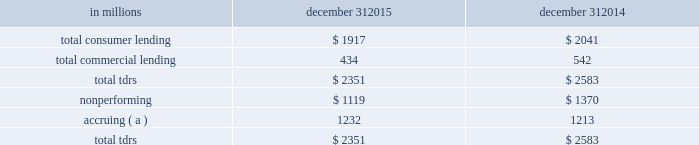Troubled debt restructurings ( tdrs ) a tdr is a loan whose terms have been restructured in a manner that grants a concession to a borrower experiencing financial difficulty .
Tdrs result from our loss mitigation activities , and include rate reductions , principal forgiveness , postponement/reduction of scheduled amortization , and extensions , which are intended to minimize economic loss and to avoid foreclosure or repossession of collateral .
Additionally , tdrs also result from borrowers that have been discharged from personal liability through chapter 7 bankruptcy and have not formally reaffirmed their loan obligations to pnc .
In those situations where principal is forgiven , the amount of such principal forgiveness is immediately charged off .
Some tdrs may not ultimately result in the full collection of principal and interest , as restructured , and result in potential incremental losses .
These potential incremental losses have been factored into our overall alll estimate .
The level of any subsequent defaults will likely be affected by future economic conditions .
Once a loan becomes a tdr , it will continue to be reported as a tdr until it is ultimately repaid in full , the collateral is foreclosed upon , or it is fully charged off .
We held specific reserves in the alll of $ .3 billion and $ .4 billion at december 31 , 2015 and december 31 , 2014 , respectively , for the total tdr portfolio .
Table 61 : summary of troubled debt restructurings in millions december 31 december 31 .
( a ) accruing loans include consumer credit card loans and loans that have demonstrated a period of at least six months of performance under the restructured terms and are excluded from nonperforming loans .
Loans where borrowers have been discharged from personal liability through chapter 7 bankruptcy and have not formally reaffirmed their loan obligations to pnc and loans to borrowers not currently obligated to make both principal and interest payments under the restructured terms are not returned to accrual status .
Table 62 quantifies the number of loans that were classified as tdrs as well as the change in the recorded investments as a result of the tdr classification during the years 2015 , 2014 and 2013 respectively .
Additionally , the table provides information about the types of tdr concessions .
The principal forgiveness tdr category includes principal forgiveness and accrued interest forgiveness .
These types of tdrs result in a write down of the recorded investment and a charge-off if such action has not already taken place .
The rate reduction tdr category includes reduced interest rate and interest deferral .
The tdrs within this category result in reductions to future interest income .
The other tdr category primarily includes consumer borrowers that have been discharged from personal liability through chapter 7 bankruptcy and have not formally reaffirmed their loan obligations to pnc , as well as postponement/reduction of scheduled amortization and contractual extensions for both consumer and commercial borrowers .
In some cases , there have been multiple concessions granted on one loan .
This is most common within the commercial loan portfolio .
When there have been multiple concessions granted in the commercial loan portfolio , the principal forgiveness concession was prioritized for purposes of determining the inclusion in table 62 .
For example , if there is principal forgiveness in conjunction with lower interest rate and postponement of amortization , the type of concession will be reported as principal forgiveness .
Second in priority would be rate reduction .
For example , if there is an interest rate reduction in conjunction with postponement of amortization , the type of concession will be reported as a rate reduction .
In the event that multiple concessions are granted on a consumer loan , concessions resulting from discharge from personal liability through chapter 7 bankruptcy without formal affirmation of the loan obligations to pnc would be prioritized and included in the other type of concession in the table below .
After that , consumer loan concessions would follow the previously discussed priority of concessions for the commercial loan portfolio .
136 the pnc financial services group , inc .
2013 form 10-k .
At 12/31/15 , nonperforming loans were what percent of total tdrs? 
Computations: (1119 / 2351)
Answer: 0.47597. 